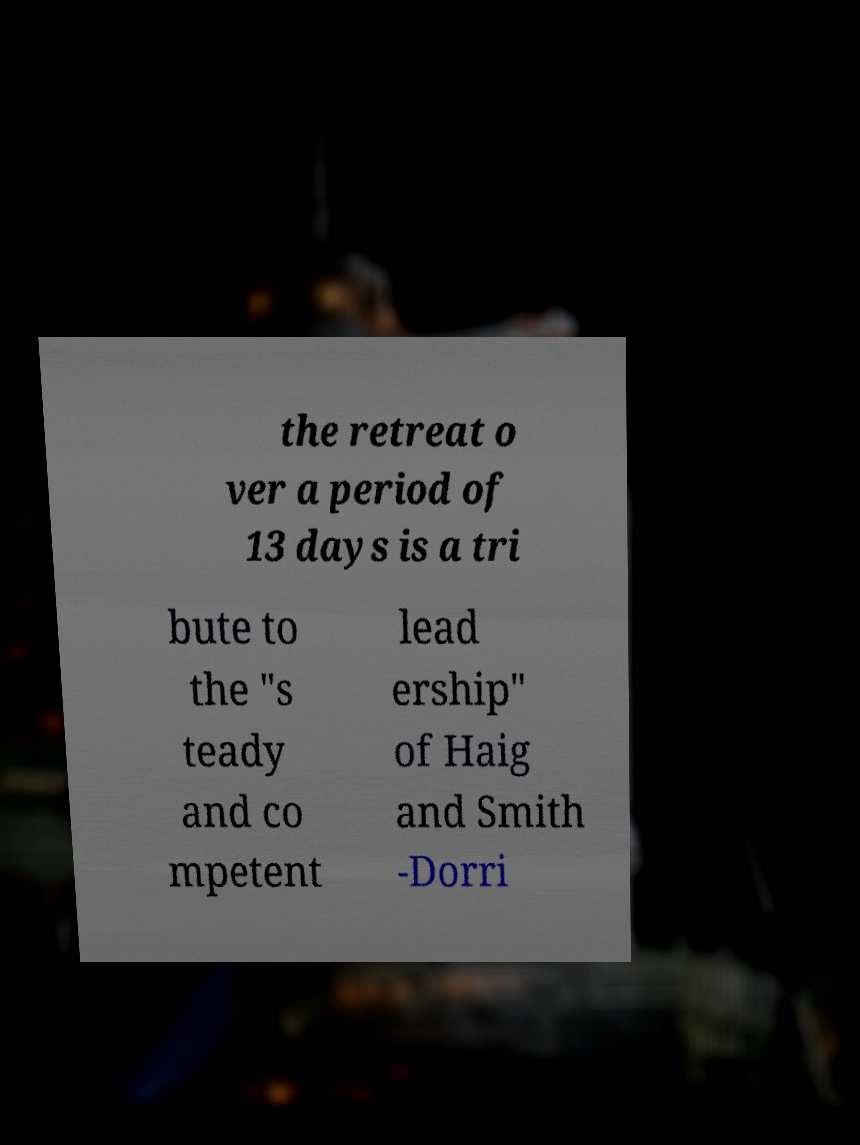For documentation purposes, I need the text within this image transcribed. Could you provide that? the retreat o ver a period of 13 days is a tri bute to the "s teady and co mpetent lead ership" of Haig and Smith -Dorri 